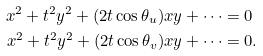<formula> <loc_0><loc_0><loc_500><loc_500>x ^ { 2 } + t ^ { 2 } y ^ { 2 } + ( 2 t \cos \theta _ { u } ) x y + \cdots & = 0 \\ x ^ { 2 } + t ^ { 2 } y ^ { 2 } + ( 2 t \cos \theta _ { v } ) x y + \cdots & = 0 .</formula> 